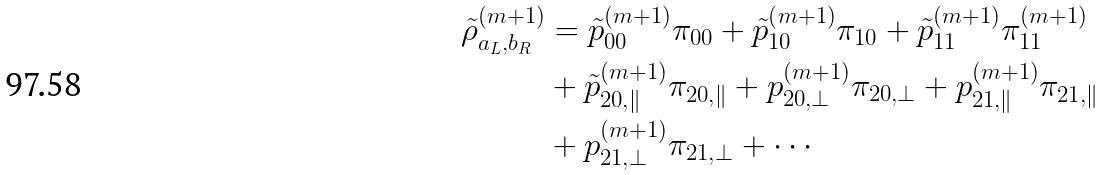Convert formula to latex. <formula><loc_0><loc_0><loc_500><loc_500>\tilde { \rho } _ { a _ { L } , b _ { R } } ^ { \left ( m + 1 \right ) } & = \tilde { p } _ { 0 0 } ^ { \left ( m + 1 \right ) } \pi _ { 0 0 } + \tilde { p } _ { 1 0 } ^ { \left ( m + 1 \right ) } \pi _ { 1 0 } + \tilde { p } _ { 1 1 } ^ { \left ( m + 1 \right ) } \pi _ { 1 1 } ^ { \left ( m + 1 \right ) } \\ & + \tilde { p } _ { 2 0 , \| } ^ { \left ( m + 1 \right ) } \pi _ { 2 0 , \| } + p _ { 2 0 , \perp } ^ { \left ( m + 1 \right ) } \pi _ { 2 0 , \perp } + p _ { 2 1 , \| } ^ { \left ( m + 1 \right ) } \pi _ { 2 1 , \| } \\ & + p _ { 2 1 , \perp } ^ { \left ( m + 1 \right ) } \pi _ { 2 1 , \perp } + \cdots</formula> 